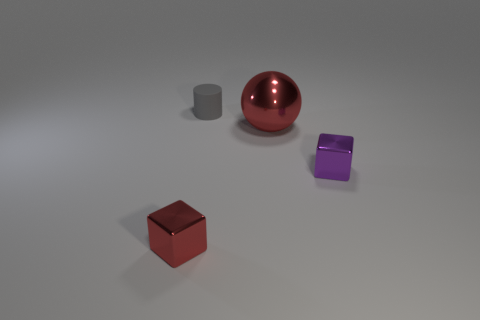Add 2 matte objects. How many objects exist? 6 Add 2 purple things. How many purple things exist? 3 Subtract all red cubes. How many cubes are left? 1 Subtract 0 yellow spheres. How many objects are left? 4 Subtract all spheres. How many objects are left? 3 Subtract 1 blocks. How many blocks are left? 1 Subtract all yellow spheres. Subtract all gray cubes. How many spheres are left? 1 Subtract all yellow spheres. How many red cubes are left? 1 Subtract all rubber objects. Subtract all red spheres. How many objects are left? 2 Add 3 rubber cylinders. How many rubber cylinders are left? 4 